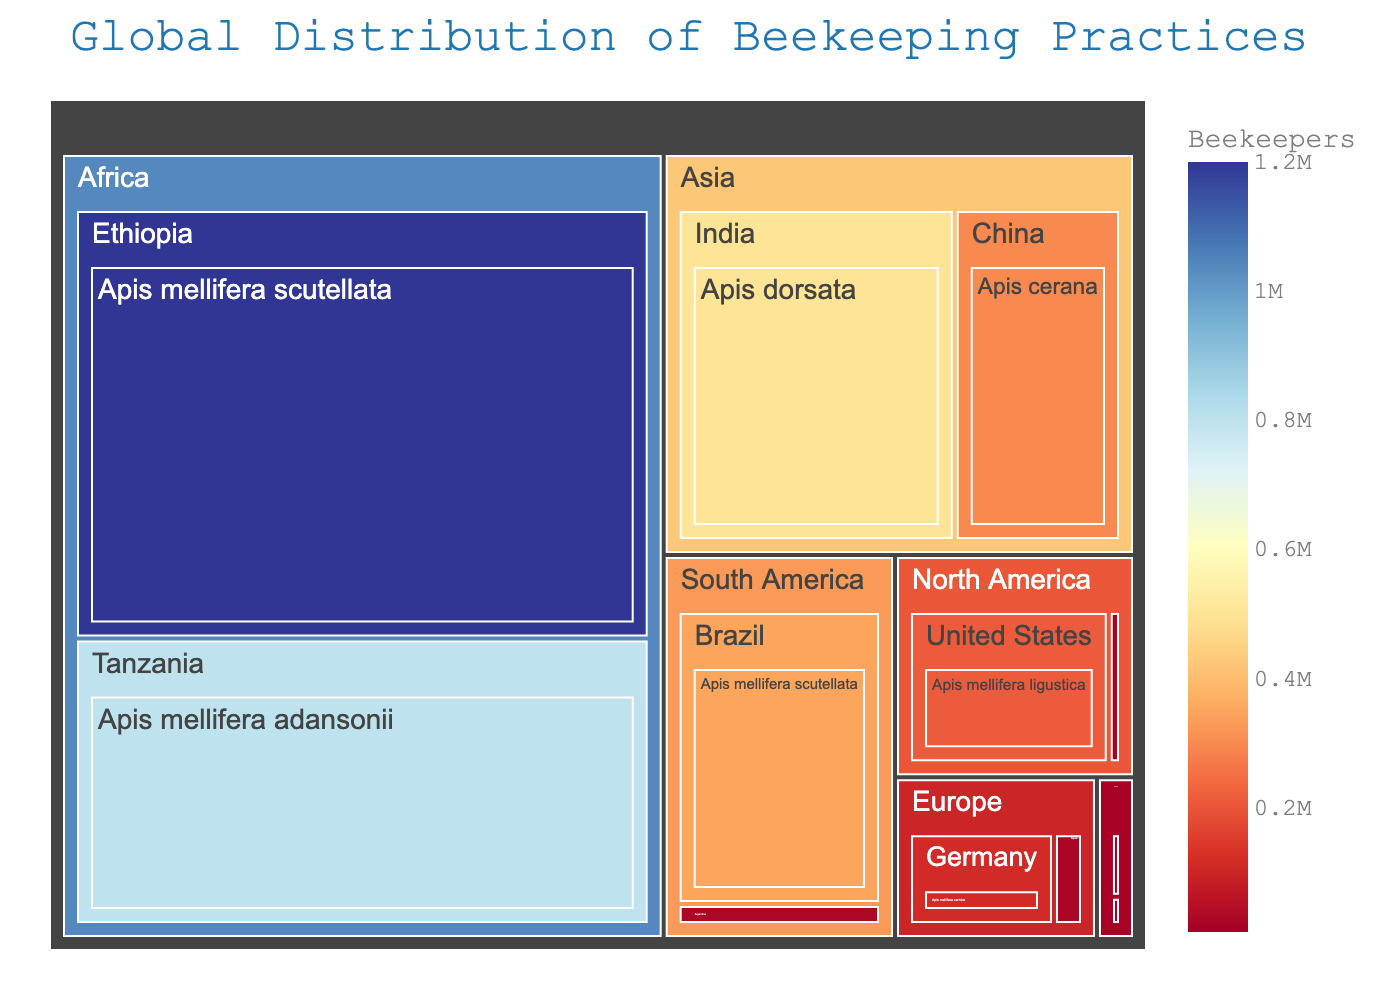What is the title of the Treemap? The title is usually the most prominent text at the top of the figure, designed to give a brief description of the chart's purpose.
Answer: Global Distribution of Beekeeping Practices Which country in Africa has the highest number of beekeepers? To find this, locate Africa on the Treemap and identify the country with the largest box representing beekeepers.
Answer: Ethiopia Among the listed continents, which one has the least number of beekeepers? By examining the total area allocated to each continent on the Treemap, the continent with the smallest combined area for its countries and bee species represents the fewest beekeepers.
Answer: Oceania How many beekeepers are there in Europe, combining all countries? Sum up the number of beekeepers in Germany (115,000) and Spain (23,000) to get the total for Europe.
Answer: 138,000 Which bee species is most commonly used in North America? By examining the boxes under the United States and Canada within North America, identify the species with the largest total area.
Answer: Apis mellifera ligustica Compare the number of beekeepers in China and India. Locate the boxes for China and India under Asia in the Treemap, and compare the values (300,000 for China and 500,000 for India).
Answer: India has more beekeepers than China Which country in the Treemap uses Apis mellifera buckfast? Find the box labeled Apis mellifera buckfast within the Treemap and identify the corresponding country.
Answer: Canada What is the total number of beekeepers in South America? Add together the number of beekeepers in Brazil (350,000) and Argentina (25,000).
Answer: 375,000 Does Tanzania have more or fewer beekeepers than Canada? Compare the number of beekeepers in Tanzania (800,000) with Canada (13,000), found within their respective continents in the Treemap.
Answer: Tanzania has more beekeepers What is the largest number of beekeepers associated with a single bee species? Identify the largest single label number listed in the Treemap for any bee species across all countries and continents.
Answer: 1,200,000 (Apis mellifera scutellata in Ethiopia) 